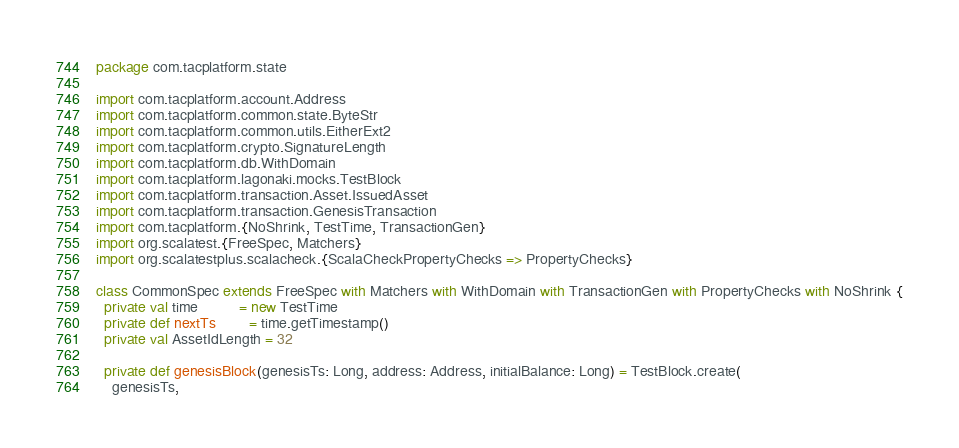<code> <loc_0><loc_0><loc_500><loc_500><_Scala_>package com.tacplatform.state

import com.tacplatform.account.Address
import com.tacplatform.common.state.ByteStr
import com.tacplatform.common.utils.EitherExt2
import com.tacplatform.crypto.SignatureLength
import com.tacplatform.db.WithDomain
import com.tacplatform.lagonaki.mocks.TestBlock
import com.tacplatform.transaction.Asset.IssuedAsset
import com.tacplatform.transaction.GenesisTransaction
import com.tacplatform.{NoShrink, TestTime, TransactionGen}
import org.scalatest.{FreeSpec, Matchers}
import org.scalatestplus.scalacheck.{ScalaCheckPropertyChecks => PropertyChecks}

class CommonSpec extends FreeSpec with Matchers with WithDomain with TransactionGen with PropertyChecks with NoShrink {
  private val time          = new TestTime
  private def nextTs        = time.getTimestamp()
  private val AssetIdLength = 32

  private def genesisBlock(genesisTs: Long, address: Address, initialBalance: Long) = TestBlock.create(
    genesisTs,</code> 